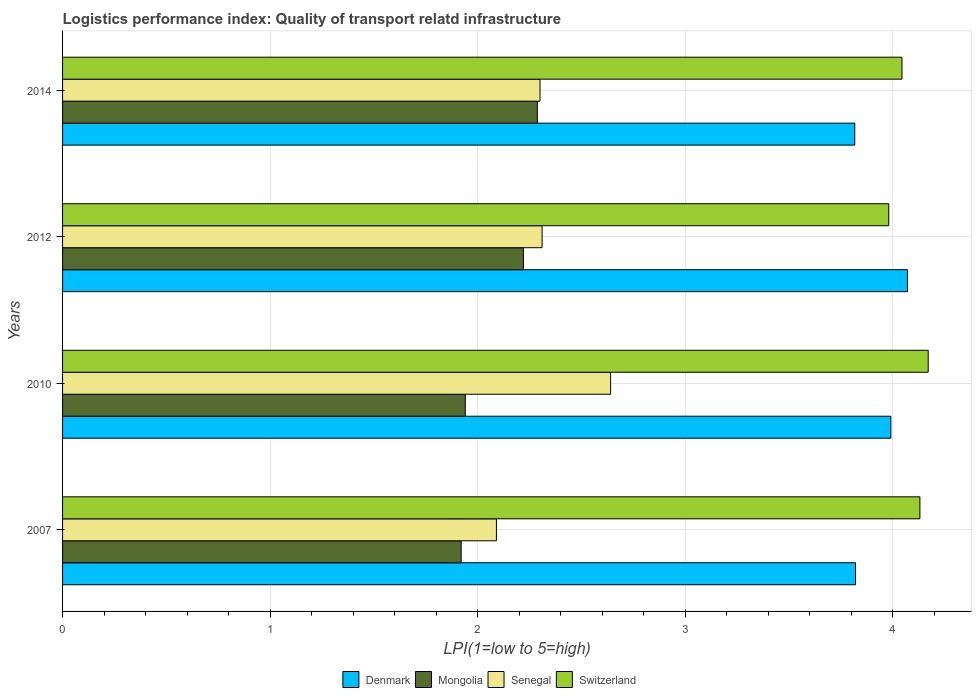How many bars are there on the 4th tick from the bottom?
Your answer should be compact. 4. What is the label of the 4th group of bars from the top?
Provide a succinct answer. 2007. What is the logistics performance index in Switzerland in 2010?
Ensure brevity in your answer.  4.17. Across all years, what is the maximum logistics performance index in Mongolia?
Provide a short and direct response. 2.29. Across all years, what is the minimum logistics performance index in Switzerland?
Ensure brevity in your answer.  3.98. In which year was the logistics performance index in Senegal maximum?
Offer a very short reply. 2010. In which year was the logistics performance index in Mongolia minimum?
Offer a terse response. 2007. What is the total logistics performance index in Denmark in the graph?
Your answer should be compact. 15.7. What is the difference between the logistics performance index in Denmark in 2010 and that in 2014?
Ensure brevity in your answer.  0.17. What is the difference between the logistics performance index in Denmark in 2010 and the logistics performance index in Switzerland in 2012?
Offer a very short reply. 0.01. What is the average logistics performance index in Senegal per year?
Provide a succinct answer. 2.33. In the year 2014, what is the difference between the logistics performance index in Senegal and logistics performance index in Switzerland?
Provide a short and direct response. -1.74. What is the ratio of the logistics performance index in Mongolia in 2007 to that in 2010?
Make the answer very short. 0.99. Is the difference between the logistics performance index in Senegal in 2010 and 2014 greater than the difference between the logistics performance index in Switzerland in 2010 and 2014?
Your answer should be very brief. Yes. What is the difference between the highest and the second highest logistics performance index in Mongolia?
Ensure brevity in your answer.  0.07. What is the difference between the highest and the lowest logistics performance index in Senegal?
Your answer should be compact. 0.55. In how many years, is the logistics performance index in Mongolia greater than the average logistics performance index in Mongolia taken over all years?
Your answer should be compact. 2. Is it the case that in every year, the sum of the logistics performance index in Switzerland and logistics performance index in Denmark is greater than the sum of logistics performance index in Mongolia and logistics performance index in Senegal?
Offer a very short reply. No. What does the 1st bar from the top in 2007 represents?
Ensure brevity in your answer.  Switzerland. What does the 4th bar from the bottom in 2010 represents?
Give a very brief answer. Switzerland. Is it the case that in every year, the sum of the logistics performance index in Mongolia and logistics performance index in Senegal is greater than the logistics performance index in Denmark?
Ensure brevity in your answer.  Yes. Are all the bars in the graph horizontal?
Your response must be concise. Yes. What is the difference between two consecutive major ticks on the X-axis?
Keep it short and to the point. 1. Are the values on the major ticks of X-axis written in scientific E-notation?
Offer a terse response. No. Does the graph contain any zero values?
Provide a short and direct response. No. Where does the legend appear in the graph?
Ensure brevity in your answer.  Bottom center. How many legend labels are there?
Keep it short and to the point. 4. How are the legend labels stacked?
Make the answer very short. Horizontal. What is the title of the graph?
Make the answer very short. Logistics performance index: Quality of transport relatd infrastructure. Does "Slovak Republic" appear as one of the legend labels in the graph?
Ensure brevity in your answer.  No. What is the label or title of the X-axis?
Give a very brief answer. LPI(1=low to 5=high). What is the LPI(1=low to 5=high) in Denmark in 2007?
Provide a succinct answer. 3.82. What is the LPI(1=low to 5=high) in Mongolia in 2007?
Your answer should be compact. 1.92. What is the LPI(1=low to 5=high) of Senegal in 2007?
Provide a short and direct response. 2.09. What is the LPI(1=low to 5=high) of Switzerland in 2007?
Give a very brief answer. 4.13. What is the LPI(1=low to 5=high) of Denmark in 2010?
Offer a terse response. 3.99. What is the LPI(1=low to 5=high) of Mongolia in 2010?
Keep it short and to the point. 1.94. What is the LPI(1=low to 5=high) in Senegal in 2010?
Keep it short and to the point. 2.64. What is the LPI(1=low to 5=high) in Switzerland in 2010?
Make the answer very short. 4.17. What is the LPI(1=low to 5=high) in Denmark in 2012?
Make the answer very short. 4.07. What is the LPI(1=low to 5=high) of Mongolia in 2012?
Offer a very short reply. 2.22. What is the LPI(1=low to 5=high) of Senegal in 2012?
Your answer should be very brief. 2.31. What is the LPI(1=low to 5=high) of Switzerland in 2012?
Your answer should be compact. 3.98. What is the LPI(1=low to 5=high) of Denmark in 2014?
Provide a short and direct response. 3.82. What is the LPI(1=low to 5=high) in Mongolia in 2014?
Provide a succinct answer. 2.29. What is the LPI(1=low to 5=high) in Switzerland in 2014?
Make the answer very short. 4.04. Across all years, what is the maximum LPI(1=low to 5=high) of Denmark?
Keep it short and to the point. 4.07. Across all years, what is the maximum LPI(1=low to 5=high) in Mongolia?
Give a very brief answer. 2.29. Across all years, what is the maximum LPI(1=low to 5=high) in Senegal?
Make the answer very short. 2.64. Across all years, what is the maximum LPI(1=low to 5=high) in Switzerland?
Offer a very short reply. 4.17. Across all years, what is the minimum LPI(1=low to 5=high) of Denmark?
Your response must be concise. 3.82. Across all years, what is the minimum LPI(1=low to 5=high) of Mongolia?
Offer a terse response. 1.92. Across all years, what is the minimum LPI(1=low to 5=high) of Senegal?
Provide a short and direct response. 2.09. Across all years, what is the minimum LPI(1=low to 5=high) of Switzerland?
Offer a terse response. 3.98. What is the total LPI(1=low to 5=high) in Denmark in the graph?
Make the answer very short. 15.7. What is the total LPI(1=low to 5=high) of Mongolia in the graph?
Your response must be concise. 8.37. What is the total LPI(1=low to 5=high) in Senegal in the graph?
Keep it short and to the point. 9.34. What is the total LPI(1=low to 5=high) of Switzerland in the graph?
Give a very brief answer. 16.32. What is the difference between the LPI(1=low to 5=high) in Denmark in 2007 and that in 2010?
Give a very brief answer. -0.17. What is the difference between the LPI(1=low to 5=high) of Mongolia in 2007 and that in 2010?
Provide a short and direct response. -0.02. What is the difference between the LPI(1=low to 5=high) of Senegal in 2007 and that in 2010?
Your response must be concise. -0.55. What is the difference between the LPI(1=low to 5=high) in Switzerland in 2007 and that in 2010?
Your answer should be compact. -0.04. What is the difference between the LPI(1=low to 5=high) of Mongolia in 2007 and that in 2012?
Your response must be concise. -0.3. What is the difference between the LPI(1=low to 5=high) in Senegal in 2007 and that in 2012?
Make the answer very short. -0.22. What is the difference between the LPI(1=low to 5=high) of Denmark in 2007 and that in 2014?
Provide a succinct answer. 0. What is the difference between the LPI(1=low to 5=high) in Mongolia in 2007 and that in 2014?
Provide a succinct answer. -0.37. What is the difference between the LPI(1=low to 5=high) of Senegal in 2007 and that in 2014?
Give a very brief answer. -0.21. What is the difference between the LPI(1=low to 5=high) of Switzerland in 2007 and that in 2014?
Make the answer very short. 0.09. What is the difference between the LPI(1=low to 5=high) in Denmark in 2010 and that in 2012?
Offer a very short reply. -0.08. What is the difference between the LPI(1=low to 5=high) in Mongolia in 2010 and that in 2012?
Ensure brevity in your answer.  -0.28. What is the difference between the LPI(1=low to 5=high) in Senegal in 2010 and that in 2012?
Make the answer very short. 0.33. What is the difference between the LPI(1=low to 5=high) in Switzerland in 2010 and that in 2012?
Make the answer very short. 0.19. What is the difference between the LPI(1=low to 5=high) in Denmark in 2010 and that in 2014?
Keep it short and to the point. 0.17. What is the difference between the LPI(1=low to 5=high) of Mongolia in 2010 and that in 2014?
Your answer should be compact. -0.35. What is the difference between the LPI(1=low to 5=high) in Senegal in 2010 and that in 2014?
Your answer should be very brief. 0.34. What is the difference between the LPI(1=low to 5=high) of Switzerland in 2010 and that in 2014?
Offer a terse response. 0.13. What is the difference between the LPI(1=low to 5=high) in Denmark in 2012 and that in 2014?
Provide a short and direct response. 0.25. What is the difference between the LPI(1=low to 5=high) in Mongolia in 2012 and that in 2014?
Ensure brevity in your answer.  -0.07. What is the difference between the LPI(1=low to 5=high) in Switzerland in 2012 and that in 2014?
Your response must be concise. -0.06. What is the difference between the LPI(1=low to 5=high) of Denmark in 2007 and the LPI(1=low to 5=high) of Mongolia in 2010?
Give a very brief answer. 1.88. What is the difference between the LPI(1=low to 5=high) of Denmark in 2007 and the LPI(1=low to 5=high) of Senegal in 2010?
Offer a terse response. 1.18. What is the difference between the LPI(1=low to 5=high) of Denmark in 2007 and the LPI(1=low to 5=high) of Switzerland in 2010?
Ensure brevity in your answer.  -0.35. What is the difference between the LPI(1=low to 5=high) in Mongolia in 2007 and the LPI(1=low to 5=high) in Senegal in 2010?
Provide a succinct answer. -0.72. What is the difference between the LPI(1=low to 5=high) in Mongolia in 2007 and the LPI(1=low to 5=high) in Switzerland in 2010?
Offer a terse response. -2.25. What is the difference between the LPI(1=low to 5=high) in Senegal in 2007 and the LPI(1=low to 5=high) in Switzerland in 2010?
Provide a short and direct response. -2.08. What is the difference between the LPI(1=low to 5=high) in Denmark in 2007 and the LPI(1=low to 5=high) in Senegal in 2012?
Your response must be concise. 1.51. What is the difference between the LPI(1=low to 5=high) of Denmark in 2007 and the LPI(1=low to 5=high) of Switzerland in 2012?
Ensure brevity in your answer.  -0.16. What is the difference between the LPI(1=low to 5=high) in Mongolia in 2007 and the LPI(1=low to 5=high) in Senegal in 2012?
Make the answer very short. -0.39. What is the difference between the LPI(1=low to 5=high) in Mongolia in 2007 and the LPI(1=low to 5=high) in Switzerland in 2012?
Your response must be concise. -2.06. What is the difference between the LPI(1=low to 5=high) of Senegal in 2007 and the LPI(1=low to 5=high) of Switzerland in 2012?
Your response must be concise. -1.89. What is the difference between the LPI(1=low to 5=high) of Denmark in 2007 and the LPI(1=low to 5=high) of Mongolia in 2014?
Offer a very short reply. 1.53. What is the difference between the LPI(1=low to 5=high) of Denmark in 2007 and the LPI(1=low to 5=high) of Senegal in 2014?
Give a very brief answer. 1.52. What is the difference between the LPI(1=low to 5=high) in Denmark in 2007 and the LPI(1=low to 5=high) in Switzerland in 2014?
Offer a very short reply. -0.22. What is the difference between the LPI(1=low to 5=high) in Mongolia in 2007 and the LPI(1=low to 5=high) in Senegal in 2014?
Provide a short and direct response. -0.38. What is the difference between the LPI(1=low to 5=high) of Mongolia in 2007 and the LPI(1=low to 5=high) of Switzerland in 2014?
Your response must be concise. -2.12. What is the difference between the LPI(1=low to 5=high) in Senegal in 2007 and the LPI(1=low to 5=high) in Switzerland in 2014?
Your answer should be compact. -1.95. What is the difference between the LPI(1=low to 5=high) in Denmark in 2010 and the LPI(1=low to 5=high) in Mongolia in 2012?
Keep it short and to the point. 1.77. What is the difference between the LPI(1=low to 5=high) in Denmark in 2010 and the LPI(1=low to 5=high) in Senegal in 2012?
Keep it short and to the point. 1.68. What is the difference between the LPI(1=low to 5=high) in Mongolia in 2010 and the LPI(1=low to 5=high) in Senegal in 2012?
Your answer should be very brief. -0.37. What is the difference between the LPI(1=low to 5=high) in Mongolia in 2010 and the LPI(1=low to 5=high) in Switzerland in 2012?
Ensure brevity in your answer.  -2.04. What is the difference between the LPI(1=low to 5=high) in Senegal in 2010 and the LPI(1=low to 5=high) in Switzerland in 2012?
Offer a terse response. -1.34. What is the difference between the LPI(1=low to 5=high) of Denmark in 2010 and the LPI(1=low to 5=high) of Mongolia in 2014?
Ensure brevity in your answer.  1.7. What is the difference between the LPI(1=low to 5=high) in Denmark in 2010 and the LPI(1=low to 5=high) in Senegal in 2014?
Provide a short and direct response. 1.69. What is the difference between the LPI(1=low to 5=high) of Denmark in 2010 and the LPI(1=low to 5=high) of Switzerland in 2014?
Provide a short and direct response. -0.05. What is the difference between the LPI(1=low to 5=high) of Mongolia in 2010 and the LPI(1=low to 5=high) of Senegal in 2014?
Ensure brevity in your answer.  -0.36. What is the difference between the LPI(1=low to 5=high) in Mongolia in 2010 and the LPI(1=low to 5=high) in Switzerland in 2014?
Your response must be concise. -2.1. What is the difference between the LPI(1=low to 5=high) in Senegal in 2010 and the LPI(1=low to 5=high) in Switzerland in 2014?
Provide a short and direct response. -1.4. What is the difference between the LPI(1=low to 5=high) of Denmark in 2012 and the LPI(1=low to 5=high) of Mongolia in 2014?
Ensure brevity in your answer.  1.78. What is the difference between the LPI(1=low to 5=high) in Denmark in 2012 and the LPI(1=low to 5=high) in Senegal in 2014?
Keep it short and to the point. 1.77. What is the difference between the LPI(1=low to 5=high) in Denmark in 2012 and the LPI(1=low to 5=high) in Switzerland in 2014?
Offer a very short reply. 0.03. What is the difference between the LPI(1=low to 5=high) in Mongolia in 2012 and the LPI(1=low to 5=high) in Senegal in 2014?
Offer a very short reply. -0.08. What is the difference between the LPI(1=low to 5=high) in Mongolia in 2012 and the LPI(1=low to 5=high) in Switzerland in 2014?
Provide a succinct answer. -1.82. What is the difference between the LPI(1=low to 5=high) of Senegal in 2012 and the LPI(1=low to 5=high) of Switzerland in 2014?
Provide a short and direct response. -1.73. What is the average LPI(1=low to 5=high) of Denmark per year?
Your response must be concise. 3.92. What is the average LPI(1=low to 5=high) of Mongolia per year?
Your answer should be compact. 2.09. What is the average LPI(1=low to 5=high) of Senegal per year?
Offer a terse response. 2.33. What is the average LPI(1=low to 5=high) in Switzerland per year?
Ensure brevity in your answer.  4.08. In the year 2007, what is the difference between the LPI(1=low to 5=high) in Denmark and LPI(1=low to 5=high) in Senegal?
Make the answer very short. 1.73. In the year 2007, what is the difference between the LPI(1=low to 5=high) of Denmark and LPI(1=low to 5=high) of Switzerland?
Your answer should be very brief. -0.31. In the year 2007, what is the difference between the LPI(1=low to 5=high) in Mongolia and LPI(1=low to 5=high) in Senegal?
Provide a short and direct response. -0.17. In the year 2007, what is the difference between the LPI(1=low to 5=high) of Mongolia and LPI(1=low to 5=high) of Switzerland?
Offer a terse response. -2.21. In the year 2007, what is the difference between the LPI(1=low to 5=high) of Senegal and LPI(1=low to 5=high) of Switzerland?
Provide a short and direct response. -2.04. In the year 2010, what is the difference between the LPI(1=low to 5=high) of Denmark and LPI(1=low to 5=high) of Mongolia?
Keep it short and to the point. 2.05. In the year 2010, what is the difference between the LPI(1=low to 5=high) in Denmark and LPI(1=low to 5=high) in Senegal?
Provide a succinct answer. 1.35. In the year 2010, what is the difference between the LPI(1=low to 5=high) of Denmark and LPI(1=low to 5=high) of Switzerland?
Give a very brief answer. -0.18. In the year 2010, what is the difference between the LPI(1=low to 5=high) of Mongolia and LPI(1=low to 5=high) of Switzerland?
Your response must be concise. -2.23. In the year 2010, what is the difference between the LPI(1=low to 5=high) of Senegal and LPI(1=low to 5=high) of Switzerland?
Ensure brevity in your answer.  -1.53. In the year 2012, what is the difference between the LPI(1=low to 5=high) in Denmark and LPI(1=low to 5=high) in Mongolia?
Your answer should be compact. 1.85. In the year 2012, what is the difference between the LPI(1=low to 5=high) of Denmark and LPI(1=low to 5=high) of Senegal?
Your answer should be very brief. 1.76. In the year 2012, what is the difference between the LPI(1=low to 5=high) in Denmark and LPI(1=low to 5=high) in Switzerland?
Your answer should be very brief. 0.09. In the year 2012, what is the difference between the LPI(1=low to 5=high) of Mongolia and LPI(1=low to 5=high) of Senegal?
Ensure brevity in your answer.  -0.09. In the year 2012, what is the difference between the LPI(1=low to 5=high) in Mongolia and LPI(1=low to 5=high) in Switzerland?
Make the answer very short. -1.76. In the year 2012, what is the difference between the LPI(1=low to 5=high) in Senegal and LPI(1=low to 5=high) in Switzerland?
Provide a succinct answer. -1.67. In the year 2014, what is the difference between the LPI(1=low to 5=high) of Denmark and LPI(1=low to 5=high) of Mongolia?
Your response must be concise. 1.53. In the year 2014, what is the difference between the LPI(1=low to 5=high) in Denmark and LPI(1=low to 5=high) in Senegal?
Your answer should be compact. 1.52. In the year 2014, what is the difference between the LPI(1=low to 5=high) of Denmark and LPI(1=low to 5=high) of Switzerland?
Offer a terse response. -0.23. In the year 2014, what is the difference between the LPI(1=low to 5=high) of Mongolia and LPI(1=low to 5=high) of Senegal?
Give a very brief answer. -0.01. In the year 2014, what is the difference between the LPI(1=low to 5=high) in Mongolia and LPI(1=low to 5=high) in Switzerland?
Your response must be concise. -1.76. In the year 2014, what is the difference between the LPI(1=low to 5=high) in Senegal and LPI(1=low to 5=high) in Switzerland?
Your answer should be very brief. -1.74. What is the ratio of the LPI(1=low to 5=high) in Denmark in 2007 to that in 2010?
Make the answer very short. 0.96. What is the ratio of the LPI(1=low to 5=high) in Mongolia in 2007 to that in 2010?
Give a very brief answer. 0.99. What is the ratio of the LPI(1=low to 5=high) in Senegal in 2007 to that in 2010?
Your answer should be very brief. 0.79. What is the ratio of the LPI(1=low to 5=high) in Denmark in 2007 to that in 2012?
Keep it short and to the point. 0.94. What is the ratio of the LPI(1=low to 5=high) of Mongolia in 2007 to that in 2012?
Provide a short and direct response. 0.86. What is the ratio of the LPI(1=low to 5=high) of Senegal in 2007 to that in 2012?
Make the answer very short. 0.9. What is the ratio of the LPI(1=low to 5=high) of Switzerland in 2007 to that in 2012?
Provide a succinct answer. 1.04. What is the ratio of the LPI(1=low to 5=high) of Denmark in 2007 to that in 2014?
Give a very brief answer. 1. What is the ratio of the LPI(1=low to 5=high) in Mongolia in 2007 to that in 2014?
Ensure brevity in your answer.  0.84. What is the ratio of the LPI(1=low to 5=high) in Senegal in 2007 to that in 2014?
Provide a short and direct response. 0.91. What is the ratio of the LPI(1=low to 5=high) in Switzerland in 2007 to that in 2014?
Offer a very short reply. 1.02. What is the ratio of the LPI(1=low to 5=high) of Denmark in 2010 to that in 2012?
Your response must be concise. 0.98. What is the ratio of the LPI(1=low to 5=high) of Mongolia in 2010 to that in 2012?
Your response must be concise. 0.87. What is the ratio of the LPI(1=low to 5=high) of Senegal in 2010 to that in 2012?
Your answer should be very brief. 1.14. What is the ratio of the LPI(1=low to 5=high) of Switzerland in 2010 to that in 2012?
Provide a short and direct response. 1.05. What is the ratio of the LPI(1=low to 5=high) of Denmark in 2010 to that in 2014?
Offer a very short reply. 1.05. What is the ratio of the LPI(1=low to 5=high) of Mongolia in 2010 to that in 2014?
Make the answer very short. 0.85. What is the ratio of the LPI(1=low to 5=high) of Senegal in 2010 to that in 2014?
Keep it short and to the point. 1.15. What is the ratio of the LPI(1=low to 5=high) of Switzerland in 2010 to that in 2014?
Provide a short and direct response. 1.03. What is the ratio of the LPI(1=low to 5=high) in Denmark in 2012 to that in 2014?
Provide a succinct answer. 1.07. What is the ratio of the LPI(1=low to 5=high) of Mongolia in 2012 to that in 2014?
Give a very brief answer. 0.97. What is the ratio of the LPI(1=low to 5=high) in Switzerland in 2012 to that in 2014?
Make the answer very short. 0.98. What is the difference between the highest and the second highest LPI(1=low to 5=high) in Mongolia?
Provide a succinct answer. 0.07. What is the difference between the highest and the second highest LPI(1=low to 5=high) of Senegal?
Offer a terse response. 0.33. What is the difference between the highest and the lowest LPI(1=low to 5=high) of Denmark?
Offer a very short reply. 0.25. What is the difference between the highest and the lowest LPI(1=low to 5=high) in Mongolia?
Offer a very short reply. 0.37. What is the difference between the highest and the lowest LPI(1=low to 5=high) in Senegal?
Provide a short and direct response. 0.55. What is the difference between the highest and the lowest LPI(1=low to 5=high) in Switzerland?
Give a very brief answer. 0.19. 